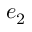<formula> <loc_0><loc_0><loc_500><loc_500>e _ { 2 }</formula> 